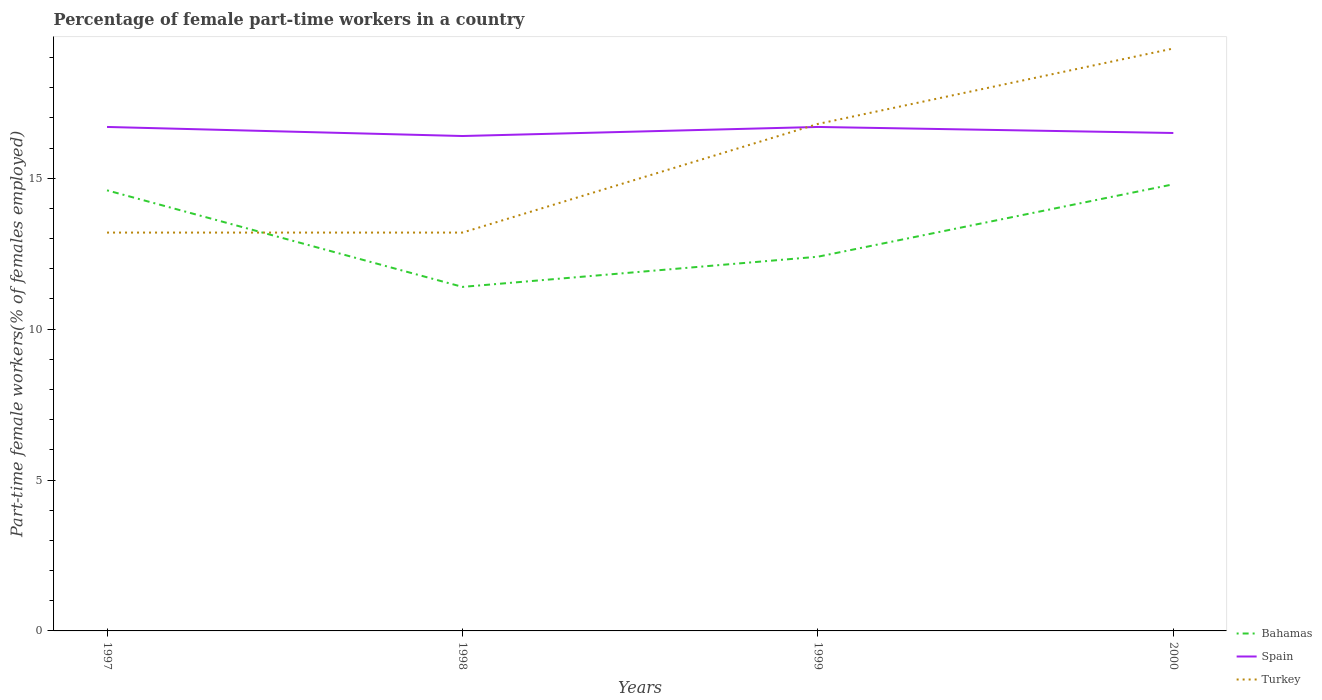Does the line corresponding to Spain intersect with the line corresponding to Turkey?
Make the answer very short. Yes. Is the number of lines equal to the number of legend labels?
Offer a very short reply. Yes. Across all years, what is the maximum percentage of female part-time workers in Turkey?
Your response must be concise. 13.2. In which year was the percentage of female part-time workers in Turkey maximum?
Make the answer very short. 1997. What is the difference between the highest and the second highest percentage of female part-time workers in Bahamas?
Provide a succinct answer. 3.4. What is the difference between the highest and the lowest percentage of female part-time workers in Turkey?
Your answer should be compact. 2. Is the percentage of female part-time workers in Turkey strictly greater than the percentage of female part-time workers in Spain over the years?
Your answer should be compact. No. How many years are there in the graph?
Your answer should be very brief. 4. Are the values on the major ticks of Y-axis written in scientific E-notation?
Keep it short and to the point. No. What is the title of the graph?
Provide a short and direct response. Percentage of female part-time workers in a country. Does "Moldova" appear as one of the legend labels in the graph?
Provide a succinct answer. No. What is the label or title of the Y-axis?
Provide a short and direct response. Part-time female workers(% of females employed). What is the Part-time female workers(% of females employed) of Bahamas in 1997?
Offer a very short reply. 14.6. What is the Part-time female workers(% of females employed) in Spain in 1997?
Your response must be concise. 16.7. What is the Part-time female workers(% of females employed) of Turkey in 1997?
Provide a short and direct response. 13.2. What is the Part-time female workers(% of females employed) in Bahamas in 1998?
Offer a very short reply. 11.4. What is the Part-time female workers(% of females employed) of Spain in 1998?
Provide a succinct answer. 16.4. What is the Part-time female workers(% of females employed) in Turkey in 1998?
Make the answer very short. 13.2. What is the Part-time female workers(% of females employed) of Bahamas in 1999?
Keep it short and to the point. 12.4. What is the Part-time female workers(% of females employed) in Spain in 1999?
Your answer should be compact. 16.7. What is the Part-time female workers(% of females employed) of Turkey in 1999?
Provide a succinct answer. 16.8. What is the Part-time female workers(% of females employed) of Bahamas in 2000?
Ensure brevity in your answer.  14.8. What is the Part-time female workers(% of females employed) in Turkey in 2000?
Offer a very short reply. 19.3. Across all years, what is the maximum Part-time female workers(% of females employed) in Bahamas?
Provide a succinct answer. 14.8. Across all years, what is the maximum Part-time female workers(% of females employed) of Spain?
Your response must be concise. 16.7. Across all years, what is the maximum Part-time female workers(% of females employed) of Turkey?
Your response must be concise. 19.3. Across all years, what is the minimum Part-time female workers(% of females employed) of Bahamas?
Your answer should be compact. 11.4. Across all years, what is the minimum Part-time female workers(% of females employed) in Spain?
Your answer should be compact. 16.4. Across all years, what is the minimum Part-time female workers(% of females employed) in Turkey?
Your answer should be very brief. 13.2. What is the total Part-time female workers(% of females employed) of Bahamas in the graph?
Give a very brief answer. 53.2. What is the total Part-time female workers(% of females employed) of Spain in the graph?
Ensure brevity in your answer.  66.3. What is the total Part-time female workers(% of females employed) of Turkey in the graph?
Your response must be concise. 62.5. What is the difference between the Part-time female workers(% of females employed) of Turkey in 1997 and that in 1999?
Your response must be concise. -3.6. What is the difference between the Part-time female workers(% of females employed) in Bahamas in 1997 and that in 2000?
Make the answer very short. -0.2. What is the difference between the Part-time female workers(% of females employed) in Spain in 1997 and that in 2000?
Offer a very short reply. 0.2. What is the difference between the Part-time female workers(% of females employed) of Spain in 1998 and that in 1999?
Offer a terse response. -0.3. What is the difference between the Part-time female workers(% of females employed) of Turkey in 1998 and that in 1999?
Offer a very short reply. -3.6. What is the difference between the Part-time female workers(% of females employed) of Turkey in 1998 and that in 2000?
Keep it short and to the point. -6.1. What is the difference between the Part-time female workers(% of females employed) of Bahamas in 1997 and the Part-time female workers(% of females employed) of Turkey in 1999?
Provide a succinct answer. -2.2. What is the difference between the Part-time female workers(% of females employed) of Spain in 1997 and the Part-time female workers(% of females employed) of Turkey in 1999?
Ensure brevity in your answer.  -0.1. What is the difference between the Part-time female workers(% of females employed) of Bahamas in 1997 and the Part-time female workers(% of females employed) of Turkey in 2000?
Provide a short and direct response. -4.7. What is the difference between the Part-time female workers(% of females employed) in Bahamas in 1998 and the Part-time female workers(% of females employed) in Turkey in 2000?
Provide a short and direct response. -7.9. What is the difference between the Part-time female workers(% of females employed) of Spain in 1998 and the Part-time female workers(% of females employed) of Turkey in 2000?
Offer a very short reply. -2.9. What is the difference between the Part-time female workers(% of females employed) of Bahamas in 1999 and the Part-time female workers(% of females employed) of Turkey in 2000?
Give a very brief answer. -6.9. What is the difference between the Part-time female workers(% of females employed) in Spain in 1999 and the Part-time female workers(% of females employed) in Turkey in 2000?
Keep it short and to the point. -2.6. What is the average Part-time female workers(% of females employed) in Spain per year?
Offer a very short reply. 16.57. What is the average Part-time female workers(% of females employed) of Turkey per year?
Give a very brief answer. 15.62. In the year 1997, what is the difference between the Part-time female workers(% of females employed) in Bahamas and Part-time female workers(% of females employed) in Spain?
Your response must be concise. -2.1. In the year 1997, what is the difference between the Part-time female workers(% of females employed) in Spain and Part-time female workers(% of females employed) in Turkey?
Offer a very short reply. 3.5. In the year 1998, what is the difference between the Part-time female workers(% of females employed) of Bahamas and Part-time female workers(% of females employed) of Turkey?
Your answer should be very brief. -1.8. In the year 1998, what is the difference between the Part-time female workers(% of females employed) of Spain and Part-time female workers(% of females employed) of Turkey?
Your response must be concise. 3.2. In the year 1999, what is the difference between the Part-time female workers(% of females employed) in Bahamas and Part-time female workers(% of females employed) in Spain?
Your answer should be compact. -4.3. In the year 1999, what is the difference between the Part-time female workers(% of females employed) in Bahamas and Part-time female workers(% of females employed) in Turkey?
Offer a terse response. -4.4. In the year 2000, what is the difference between the Part-time female workers(% of females employed) in Bahamas and Part-time female workers(% of females employed) in Spain?
Offer a terse response. -1.7. In the year 2000, what is the difference between the Part-time female workers(% of females employed) of Spain and Part-time female workers(% of females employed) of Turkey?
Your response must be concise. -2.8. What is the ratio of the Part-time female workers(% of females employed) of Bahamas in 1997 to that in 1998?
Keep it short and to the point. 1.28. What is the ratio of the Part-time female workers(% of females employed) in Spain in 1997 to that in 1998?
Make the answer very short. 1.02. What is the ratio of the Part-time female workers(% of females employed) of Turkey in 1997 to that in 1998?
Make the answer very short. 1. What is the ratio of the Part-time female workers(% of females employed) in Bahamas in 1997 to that in 1999?
Provide a short and direct response. 1.18. What is the ratio of the Part-time female workers(% of females employed) of Spain in 1997 to that in 1999?
Offer a very short reply. 1. What is the ratio of the Part-time female workers(% of females employed) in Turkey in 1997 to that in 1999?
Your answer should be compact. 0.79. What is the ratio of the Part-time female workers(% of females employed) of Bahamas in 1997 to that in 2000?
Give a very brief answer. 0.99. What is the ratio of the Part-time female workers(% of females employed) of Spain in 1997 to that in 2000?
Make the answer very short. 1.01. What is the ratio of the Part-time female workers(% of females employed) in Turkey in 1997 to that in 2000?
Provide a short and direct response. 0.68. What is the ratio of the Part-time female workers(% of females employed) of Bahamas in 1998 to that in 1999?
Provide a short and direct response. 0.92. What is the ratio of the Part-time female workers(% of females employed) of Turkey in 1998 to that in 1999?
Your answer should be compact. 0.79. What is the ratio of the Part-time female workers(% of females employed) of Bahamas in 1998 to that in 2000?
Offer a terse response. 0.77. What is the ratio of the Part-time female workers(% of females employed) in Spain in 1998 to that in 2000?
Offer a terse response. 0.99. What is the ratio of the Part-time female workers(% of females employed) of Turkey in 1998 to that in 2000?
Keep it short and to the point. 0.68. What is the ratio of the Part-time female workers(% of females employed) of Bahamas in 1999 to that in 2000?
Offer a very short reply. 0.84. What is the ratio of the Part-time female workers(% of females employed) in Spain in 1999 to that in 2000?
Offer a very short reply. 1.01. What is the ratio of the Part-time female workers(% of females employed) of Turkey in 1999 to that in 2000?
Give a very brief answer. 0.87. What is the difference between the highest and the second highest Part-time female workers(% of females employed) of Turkey?
Keep it short and to the point. 2.5. What is the difference between the highest and the lowest Part-time female workers(% of females employed) of Bahamas?
Ensure brevity in your answer.  3.4. What is the difference between the highest and the lowest Part-time female workers(% of females employed) of Turkey?
Provide a succinct answer. 6.1. 